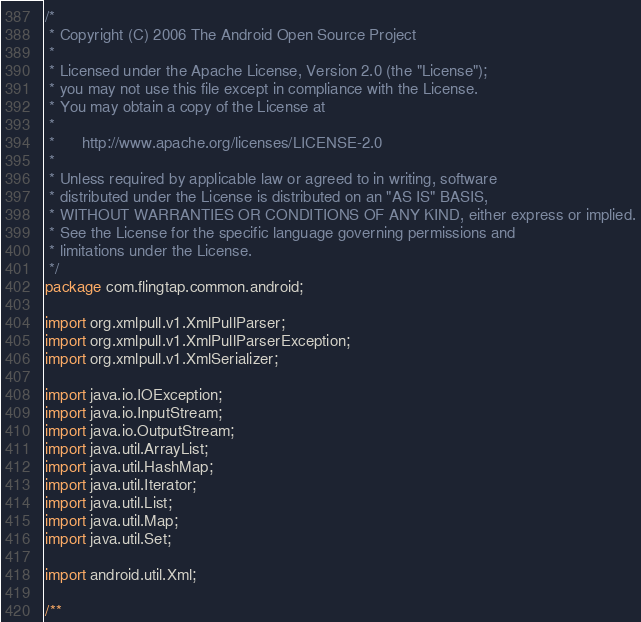<code> <loc_0><loc_0><loc_500><loc_500><_Java_>/*
 * Copyright (C) 2006 The Android Open Source Project
 *
 * Licensed under the Apache License, Version 2.0 (the "License");
 * you may not use this file except in compliance with the License.
 * You may obtain a copy of the License at
 *
 *      http://www.apache.org/licenses/LICENSE-2.0
 *
 * Unless required by applicable law or agreed to in writing, software
 * distributed under the License is distributed on an "AS IS" BASIS,
 * WITHOUT WARRANTIES OR CONDITIONS OF ANY KIND, either express or implied.
 * See the License for the specific language governing permissions and
 * limitations under the License.
 */
package com.flingtap.common.android;

import org.xmlpull.v1.XmlPullParser;
import org.xmlpull.v1.XmlPullParserException;
import org.xmlpull.v1.XmlSerializer;

import java.io.IOException;
import java.io.InputStream;
import java.io.OutputStream;
import java.util.ArrayList;
import java.util.HashMap;
import java.util.Iterator;
import java.util.List;
import java.util.Map;
import java.util.Set;

import android.util.Xml;

/**</code> 